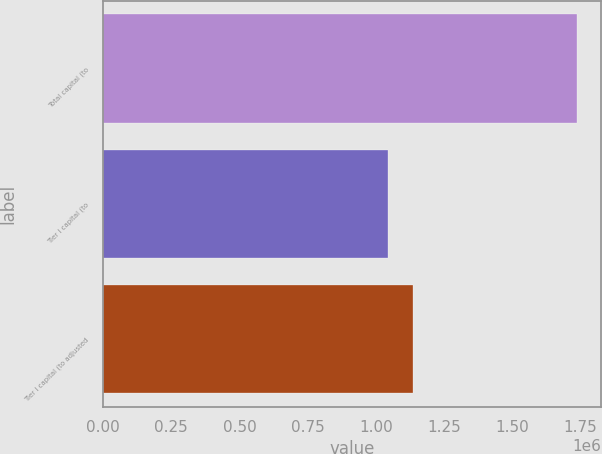Convert chart. <chart><loc_0><loc_0><loc_500><loc_500><bar_chart><fcel>Total capital (to<fcel>Tier I capital (to<fcel>Tier I capital (to adjusted<nl><fcel>1.73997e+06<fcel>1.0459e+06<fcel>1.13607e+06<nl></chart> 